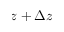Convert formula to latex. <formula><loc_0><loc_0><loc_500><loc_500>z + \Delta z</formula> 